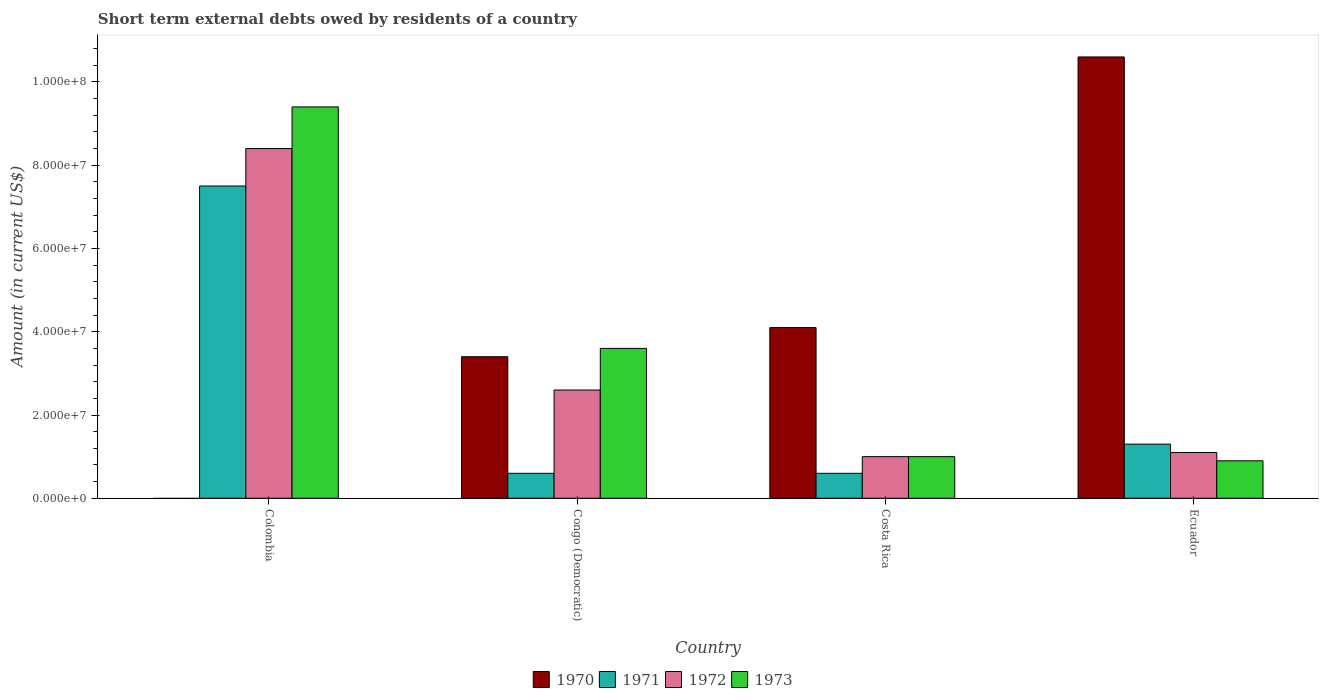How many different coloured bars are there?
Ensure brevity in your answer.  4. How many groups of bars are there?
Your answer should be compact. 4. Are the number of bars per tick equal to the number of legend labels?
Your answer should be compact. No. Are the number of bars on each tick of the X-axis equal?
Your answer should be compact. No. How many bars are there on the 3rd tick from the right?
Give a very brief answer. 4. What is the label of the 2nd group of bars from the left?
Ensure brevity in your answer.  Congo (Democratic). In how many cases, is the number of bars for a given country not equal to the number of legend labels?
Offer a terse response. 1. What is the amount of short-term external debts owed by residents in 1970 in Colombia?
Ensure brevity in your answer.  0. Across all countries, what is the maximum amount of short-term external debts owed by residents in 1970?
Make the answer very short. 1.06e+08. Across all countries, what is the minimum amount of short-term external debts owed by residents in 1973?
Ensure brevity in your answer.  9.00e+06. What is the total amount of short-term external debts owed by residents in 1972 in the graph?
Offer a terse response. 1.31e+08. What is the difference between the amount of short-term external debts owed by residents in 1973 in Congo (Democratic) and that in Ecuador?
Your answer should be very brief. 2.70e+07. What is the difference between the amount of short-term external debts owed by residents in 1972 in Ecuador and the amount of short-term external debts owed by residents in 1971 in Colombia?
Your answer should be compact. -6.40e+07. What is the average amount of short-term external debts owed by residents in 1973 per country?
Ensure brevity in your answer.  3.72e+07. What is the difference between the amount of short-term external debts owed by residents of/in 1971 and amount of short-term external debts owed by residents of/in 1973 in Congo (Democratic)?
Keep it short and to the point. -3.00e+07. What is the ratio of the amount of short-term external debts owed by residents in 1970 in Congo (Democratic) to that in Costa Rica?
Provide a short and direct response. 0.83. What is the difference between the highest and the second highest amount of short-term external debts owed by residents in 1972?
Offer a very short reply. 5.80e+07. What is the difference between the highest and the lowest amount of short-term external debts owed by residents in 1971?
Your answer should be compact. 6.90e+07. Is the sum of the amount of short-term external debts owed by residents in 1971 in Congo (Democratic) and Costa Rica greater than the maximum amount of short-term external debts owed by residents in 1972 across all countries?
Keep it short and to the point. No. Is it the case that in every country, the sum of the amount of short-term external debts owed by residents in 1973 and amount of short-term external debts owed by residents in 1970 is greater than the sum of amount of short-term external debts owed by residents in 1971 and amount of short-term external debts owed by residents in 1972?
Provide a short and direct response. No. How many bars are there?
Your answer should be very brief. 15. What is the difference between two consecutive major ticks on the Y-axis?
Ensure brevity in your answer.  2.00e+07. Are the values on the major ticks of Y-axis written in scientific E-notation?
Your answer should be compact. Yes. Does the graph contain any zero values?
Keep it short and to the point. Yes. Does the graph contain grids?
Ensure brevity in your answer.  No. Where does the legend appear in the graph?
Your answer should be compact. Bottom center. How many legend labels are there?
Keep it short and to the point. 4. How are the legend labels stacked?
Make the answer very short. Horizontal. What is the title of the graph?
Keep it short and to the point. Short term external debts owed by residents of a country. What is the Amount (in current US$) in 1970 in Colombia?
Your response must be concise. 0. What is the Amount (in current US$) of 1971 in Colombia?
Provide a succinct answer. 7.50e+07. What is the Amount (in current US$) in 1972 in Colombia?
Keep it short and to the point. 8.40e+07. What is the Amount (in current US$) of 1973 in Colombia?
Offer a terse response. 9.40e+07. What is the Amount (in current US$) of 1970 in Congo (Democratic)?
Ensure brevity in your answer.  3.40e+07. What is the Amount (in current US$) in 1971 in Congo (Democratic)?
Provide a short and direct response. 6.00e+06. What is the Amount (in current US$) in 1972 in Congo (Democratic)?
Give a very brief answer. 2.60e+07. What is the Amount (in current US$) of 1973 in Congo (Democratic)?
Offer a terse response. 3.60e+07. What is the Amount (in current US$) of 1970 in Costa Rica?
Keep it short and to the point. 4.10e+07. What is the Amount (in current US$) in 1972 in Costa Rica?
Offer a very short reply. 1.00e+07. What is the Amount (in current US$) in 1970 in Ecuador?
Your answer should be very brief. 1.06e+08. What is the Amount (in current US$) in 1971 in Ecuador?
Your answer should be very brief. 1.30e+07. What is the Amount (in current US$) of 1972 in Ecuador?
Your answer should be compact. 1.10e+07. What is the Amount (in current US$) of 1973 in Ecuador?
Give a very brief answer. 9.00e+06. Across all countries, what is the maximum Amount (in current US$) in 1970?
Ensure brevity in your answer.  1.06e+08. Across all countries, what is the maximum Amount (in current US$) of 1971?
Give a very brief answer. 7.50e+07. Across all countries, what is the maximum Amount (in current US$) in 1972?
Offer a very short reply. 8.40e+07. Across all countries, what is the maximum Amount (in current US$) in 1973?
Provide a succinct answer. 9.40e+07. Across all countries, what is the minimum Amount (in current US$) in 1972?
Offer a very short reply. 1.00e+07. Across all countries, what is the minimum Amount (in current US$) of 1973?
Your response must be concise. 9.00e+06. What is the total Amount (in current US$) in 1970 in the graph?
Offer a very short reply. 1.81e+08. What is the total Amount (in current US$) in 1972 in the graph?
Give a very brief answer. 1.31e+08. What is the total Amount (in current US$) of 1973 in the graph?
Your answer should be very brief. 1.49e+08. What is the difference between the Amount (in current US$) of 1971 in Colombia and that in Congo (Democratic)?
Give a very brief answer. 6.90e+07. What is the difference between the Amount (in current US$) of 1972 in Colombia and that in Congo (Democratic)?
Your response must be concise. 5.80e+07. What is the difference between the Amount (in current US$) of 1973 in Colombia and that in Congo (Democratic)?
Your answer should be very brief. 5.80e+07. What is the difference between the Amount (in current US$) of 1971 in Colombia and that in Costa Rica?
Offer a very short reply. 6.90e+07. What is the difference between the Amount (in current US$) of 1972 in Colombia and that in Costa Rica?
Your answer should be very brief. 7.40e+07. What is the difference between the Amount (in current US$) of 1973 in Colombia and that in Costa Rica?
Offer a very short reply. 8.40e+07. What is the difference between the Amount (in current US$) in 1971 in Colombia and that in Ecuador?
Give a very brief answer. 6.20e+07. What is the difference between the Amount (in current US$) in 1972 in Colombia and that in Ecuador?
Offer a terse response. 7.30e+07. What is the difference between the Amount (in current US$) of 1973 in Colombia and that in Ecuador?
Keep it short and to the point. 8.50e+07. What is the difference between the Amount (in current US$) in 1970 in Congo (Democratic) and that in Costa Rica?
Provide a short and direct response. -7.00e+06. What is the difference between the Amount (in current US$) of 1972 in Congo (Democratic) and that in Costa Rica?
Offer a very short reply. 1.60e+07. What is the difference between the Amount (in current US$) in 1973 in Congo (Democratic) and that in Costa Rica?
Make the answer very short. 2.60e+07. What is the difference between the Amount (in current US$) in 1970 in Congo (Democratic) and that in Ecuador?
Offer a very short reply. -7.20e+07. What is the difference between the Amount (in current US$) of 1971 in Congo (Democratic) and that in Ecuador?
Your response must be concise. -7.00e+06. What is the difference between the Amount (in current US$) in 1972 in Congo (Democratic) and that in Ecuador?
Your response must be concise. 1.50e+07. What is the difference between the Amount (in current US$) in 1973 in Congo (Democratic) and that in Ecuador?
Your answer should be very brief. 2.70e+07. What is the difference between the Amount (in current US$) in 1970 in Costa Rica and that in Ecuador?
Your answer should be compact. -6.50e+07. What is the difference between the Amount (in current US$) of 1971 in Costa Rica and that in Ecuador?
Keep it short and to the point. -7.00e+06. What is the difference between the Amount (in current US$) in 1971 in Colombia and the Amount (in current US$) in 1972 in Congo (Democratic)?
Give a very brief answer. 4.90e+07. What is the difference between the Amount (in current US$) in 1971 in Colombia and the Amount (in current US$) in 1973 in Congo (Democratic)?
Your response must be concise. 3.90e+07. What is the difference between the Amount (in current US$) in 1972 in Colombia and the Amount (in current US$) in 1973 in Congo (Democratic)?
Your response must be concise. 4.80e+07. What is the difference between the Amount (in current US$) of 1971 in Colombia and the Amount (in current US$) of 1972 in Costa Rica?
Give a very brief answer. 6.50e+07. What is the difference between the Amount (in current US$) in 1971 in Colombia and the Amount (in current US$) in 1973 in Costa Rica?
Your response must be concise. 6.50e+07. What is the difference between the Amount (in current US$) in 1972 in Colombia and the Amount (in current US$) in 1973 in Costa Rica?
Give a very brief answer. 7.40e+07. What is the difference between the Amount (in current US$) in 1971 in Colombia and the Amount (in current US$) in 1972 in Ecuador?
Your response must be concise. 6.40e+07. What is the difference between the Amount (in current US$) in 1971 in Colombia and the Amount (in current US$) in 1973 in Ecuador?
Your response must be concise. 6.60e+07. What is the difference between the Amount (in current US$) in 1972 in Colombia and the Amount (in current US$) in 1973 in Ecuador?
Make the answer very short. 7.50e+07. What is the difference between the Amount (in current US$) in 1970 in Congo (Democratic) and the Amount (in current US$) in 1971 in Costa Rica?
Make the answer very short. 2.80e+07. What is the difference between the Amount (in current US$) of 1970 in Congo (Democratic) and the Amount (in current US$) of 1972 in Costa Rica?
Provide a short and direct response. 2.40e+07. What is the difference between the Amount (in current US$) in 1970 in Congo (Democratic) and the Amount (in current US$) in 1973 in Costa Rica?
Your answer should be very brief. 2.40e+07. What is the difference between the Amount (in current US$) of 1971 in Congo (Democratic) and the Amount (in current US$) of 1972 in Costa Rica?
Your response must be concise. -4.00e+06. What is the difference between the Amount (in current US$) in 1972 in Congo (Democratic) and the Amount (in current US$) in 1973 in Costa Rica?
Provide a short and direct response. 1.60e+07. What is the difference between the Amount (in current US$) of 1970 in Congo (Democratic) and the Amount (in current US$) of 1971 in Ecuador?
Offer a terse response. 2.10e+07. What is the difference between the Amount (in current US$) in 1970 in Congo (Democratic) and the Amount (in current US$) in 1972 in Ecuador?
Your response must be concise. 2.30e+07. What is the difference between the Amount (in current US$) in 1970 in Congo (Democratic) and the Amount (in current US$) in 1973 in Ecuador?
Ensure brevity in your answer.  2.50e+07. What is the difference between the Amount (in current US$) in 1971 in Congo (Democratic) and the Amount (in current US$) in 1972 in Ecuador?
Keep it short and to the point. -5.00e+06. What is the difference between the Amount (in current US$) of 1971 in Congo (Democratic) and the Amount (in current US$) of 1973 in Ecuador?
Your answer should be very brief. -3.00e+06. What is the difference between the Amount (in current US$) in 1972 in Congo (Democratic) and the Amount (in current US$) in 1973 in Ecuador?
Offer a terse response. 1.70e+07. What is the difference between the Amount (in current US$) in 1970 in Costa Rica and the Amount (in current US$) in 1971 in Ecuador?
Ensure brevity in your answer.  2.80e+07. What is the difference between the Amount (in current US$) of 1970 in Costa Rica and the Amount (in current US$) of 1972 in Ecuador?
Keep it short and to the point. 3.00e+07. What is the difference between the Amount (in current US$) in 1970 in Costa Rica and the Amount (in current US$) in 1973 in Ecuador?
Offer a very short reply. 3.20e+07. What is the difference between the Amount (in current US$) of 1971 in Costa Rica and the Amount (in current US$) of 1972 in Ecuador?
Your response must be concise. -5.00e+06. What is the difference between the Amount (in current US$) of 1971 in Costa Rica and the Amount (in current US$) of 1973 in Ecuador?
Your answer should be compact. -3.00e+06. What is the average Amount (in current US$) of 1970 per country?
Keep it short and to the point. 4.52e+07. What is the average Amount (in current US$) of 1971 per country?
Keep it short and to the point. 2.50e+07. What is the average Amount (in current US$) in 1972 per country?
Make the answer very short. 3.28e+07. What is the average Amount (in current US$) of 1973 per country?
Give a very brief answer. 3.72e+07. What is the difference between the Amount (in current US$) of 1971 and Amount (in current US$) of 1972 in Colombia?
Provide a short and direct response. -9.00e+06. What is the difference between the Amount (in current US$) of 1971 and Amount (in current US$) of 1973 in Colombia?
Provide a succinct answer. -1.90e+07. What is the difference between the Amount (in current US$) of 1972 and Amount (in current US$) of 1973 in Colombia?
Keep it short and to the point. -1.00e+07. What is the difference between the Amount (in current US$) of 1970 and Amount (in current US$) of 1971 in Congo (Democratic)?
Your answer should be compact. 2.80e+07. What is the difference between the Amount (in current US$) in 1970 and Amount (in current US$) in 1972 in Congo (Democratic)?
Offer a very short reply. 8.00e+06. What is the difference between the Amount (in current US$) of 1970 and Amount (in current US$) of 1973 in Congo (Democratic)?
Your response must be concise. -2.00e+06. What is the difference between the Amount (in current US$) in 1971 and Amount (in current US$) in 1972 in Congo (Democratic)?
Keep it short and to the point. -2.00e+07. What is the difference between the Amount (in current US$) in 1971 and Amount (in current US$) in 1973 in Congo (Democratic)?
Your response must be concise. -3.00e+07. What is the difference between the Amount (in current US$) in 1972 and Amount (in current US$) in 1973 in Congo (Democratic)?
Make the answer very short. -1.00e+07. What is the difference between the Amount (in current US$) in 1970 and Amount (in current US$) in 1971 in Costa Rica?
Your response must be concise. 3.50e+07. What is the difference between the Amount (in current US$) of 1970 and Amount (in current US$) of 1972 in Costa Rica?
Your answer should be compact. 3.10e+07. What is the difference between the Amount (in current US$) of 1970 and Amount (in current US$) of 1973 in Costa Rica?
Your answer should be compact. 3.10e+07. What is the difference between the Amount (in current US$) in 1971 and Amount (in current US$) in 1973 in Costa Rica?
Give a very brief answer. -4.00e+06. What is the difference between the Amount (in current US$) of 1970 and Amount (in current US$) of 1971 in Ecuador?
Provide a succinct answer. 9.30e+07. What is the difference between the Amount (in current US$) in 1970 and Amount (in current US$) in 1972 in Ecuador?
Offer a very short reply. 9.50e+07. What is the difference between the Amount (in current US$) in 1970 and Amount (in current US$) in 1973 in Ecuador?
Keep it short and to the point. 9.70e+07. What is the difference between the Amount (in current US$) in 1971 and Amount (in current US$) in 1972 in Ecuador?
Keep it short and to the point. 2.00e+06. What is the ratio of the Amount (in current US$) in 1971 in Colombia to that in Congo (Democratic)?
Give a very brief answer. 12.5. What is the ratio of the Amount (in current US$) in 1972 in Colombia to that in Congo (Democratic)?
Offer a very short reply. 3.23. What is the ratio of the Amount (in current US$) of 1973 in Colombia to that in Congo (Democratic)?
Provide a succinct answer. 2.61. What is the ratio of the Amount (in current US$) of 1972 in Colombia to that in Costa Rica?
Provide a short and direct response. 8.4. What is the ratio of the Amount (in current US$) of 1971 in Colombia to that in Ecuador?
Make the answer very short. 5.77. What is the ratio of the Amount (in current US$) of 1972 in Colombia to that in Ecuador?
Provide a succinct answer. 7.64. What is the ratio of the Amount (in current US$) in 1973 in Colombia to that in Ecuador?
Give a very brief answer. 10.44. What is the ratio of the Amount (in current US$) in 1970 in Congo (Democratic) to that in Costa Rica?
Your response must be concise. 0.83. What is the ratio of the Amount (in current US$) of 1971 in Congo (Democratic) to that in Costa Rica?
Keep it short and to the point. 1. What is the ratio of the Amount (in current US$) of 1972 in Congo (Democratic) to that in Costa Rica?
Your answer should be compact. 2.6. What is the ratio of the Amount (in current US$) in 1973 in Congo (Democratic) to that in Costa Rica?
Your answer should be very brief. 3.6. What is the ratio of the Amount (in current US$) of 1970 in Congo (Democratic) to that in Ecuador?
Your answer should be very brief. 0.32. What is the ratio of the Amount (in current US$) in 1971 in Congo (Democratic) to that in Ecuador?
Provide a short and direct response. 0.46. What is the ratio of the Amount (in current US$) of 1972 in Congo (Democratic) to that in Ecuador?
Provide a short and direct response. 2.36. What is the ratio of the Amount (in current US$) in 1973 in Congo (Democratic) to that in Ecuador?
Offer a terse response. 4. What is the ratio of the Amount (in current US$) of 1970 in Costa Rica to that in Ecuador?
Keep it short and to the point. 0.39. What is the ratio of the Amount (in current US$) in 1971 in Costa Rica to that in Ecuador?
Make the answer very short. 0.46. What is the ratio of the Amount (in current US$) in 1973 in Costa Rica to that in Ecuador?
Keep it short and to the point. 1.11. What is the difference between the highest and the second highest Amount (in current US$) of 1970?
Provide a short and direct response. 6.50e+07. What is the difference between the highest and the second highest Amount (in current US$) in 1971?
Make the answer very short. 6.20e+07. What is the difference between the highest and the second highest Amount (in current US$) in 1972?
Ensure brevity in your answer.  5.80e+07. What is the difference between the highest and the second highest Amount (in current US$) in 1973?
Offer a terse response. 5.80e+07. What is the difference between the highest and the lowest Amount (in current US$) of 1970?
Your answer should be very brief. 1.06e+08. What is the difference between the highest and the lowest Amount (in current US$) of 1971?
Offer a terse response. 6.90e+07. What is the difference between the highest and the lowest Amount (in current US$) of 1972?
Ensure brevity in your answer.  7.40e+07. What is the difference between the highest and the lowest Amount (in current US$) in 1973?
Your response must be concise. 8.50e+07. 